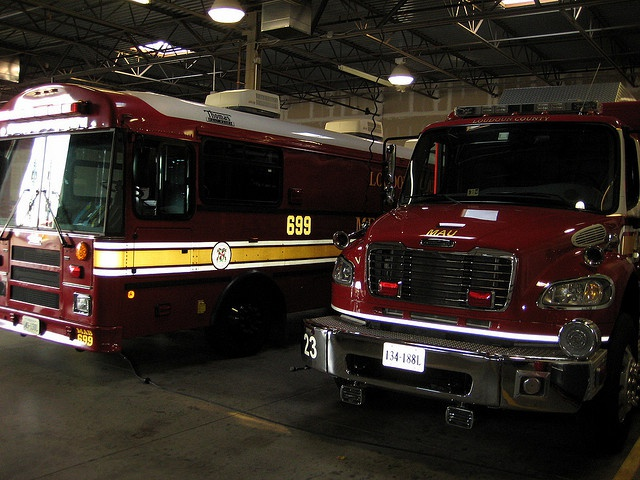Describe the objects in this image and their specific colors. I can see truck in black, maroon, gray, and white tones and bus in black, white, maroon, and gray tones in this image. 